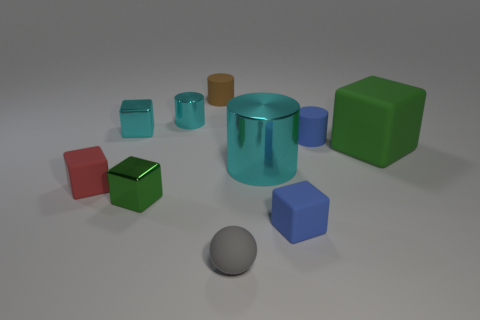Subtract all small shiny blocks. How many blocks are left? 3 Subtract 3 cylinders. How many cylinders are left? 1 Subtract all blue cylinders. How many cylinders are left? 3 Subtract all cylinders. How many objects are left? 6 Subtract all cyan cubes. How many blue cylinders are left? 1 Subtract all green metal blocks. Subtract all tiny cyan cylinders. How many objects are left? 8 Add 4 blue rubber blocks. How many blue rubber blocks are left? 5 Add 6 yellow objects. How many yellow objects exist? 6 Subtract 0 red cylinders. How many objects are left? 10 Subtract all yellow cylinders. Subtract all purple spheres. How many cylinders are left? 4 